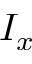Convert formula to latex. <formula><loc_0><loc_0><loc_500><loc_500>I _ { x }</formula> 